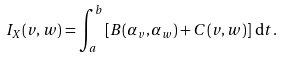<formula> <loc_0><loc_0><loc_500><loc_500>I _ { X } ( v , w ) = \int _ { a } ^ { b } \left [ B ( \alpha _ { v } , \alpha _ { w } ) + C ( v , w ) \right ] \, \mathrm d t .</formula> 